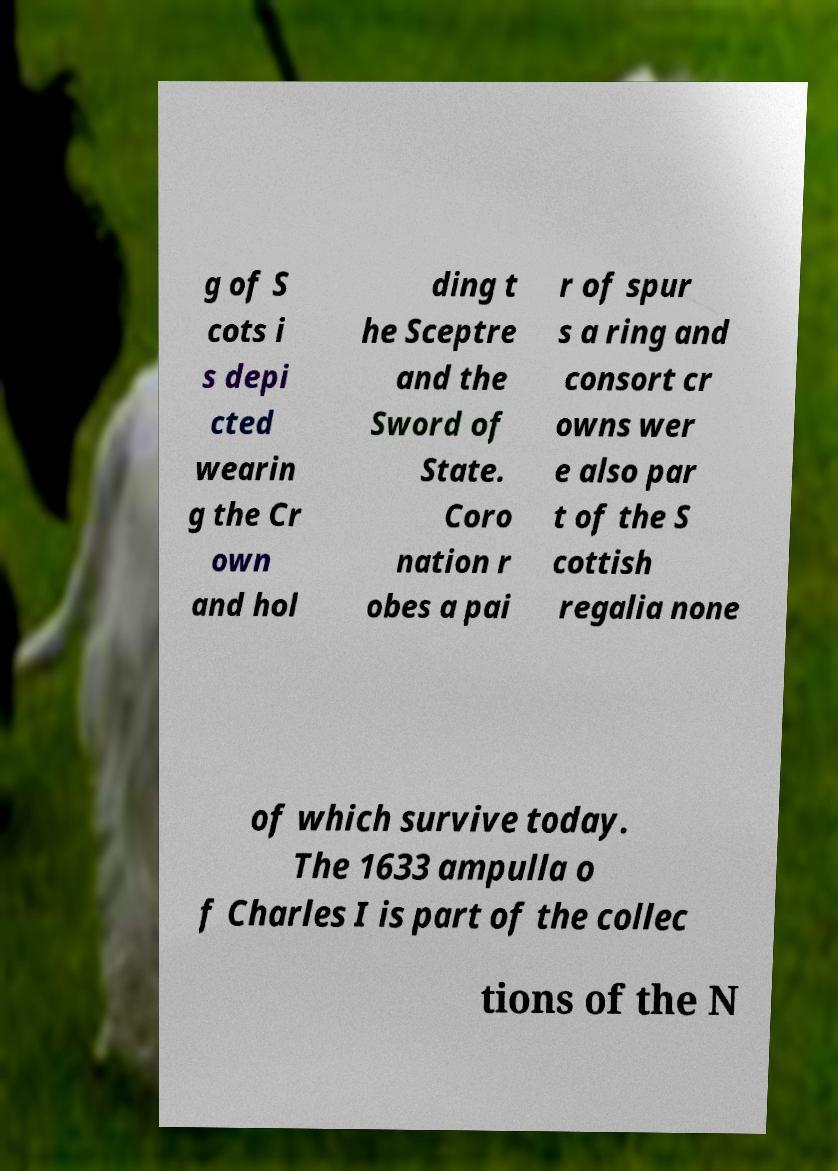I need the written content from this picture converted into text. Can you do that? g of S cots i s depi cted wearin g the Cr own and hol ding t he Sceptre and the Sword of State. Coro nation r obes a pai r of spur s a ring and consort cr owns wer e also par t of the S cottish regalia none of which survive today. The 1633 ampulla o f Charles I is part of the collec tions of the N 